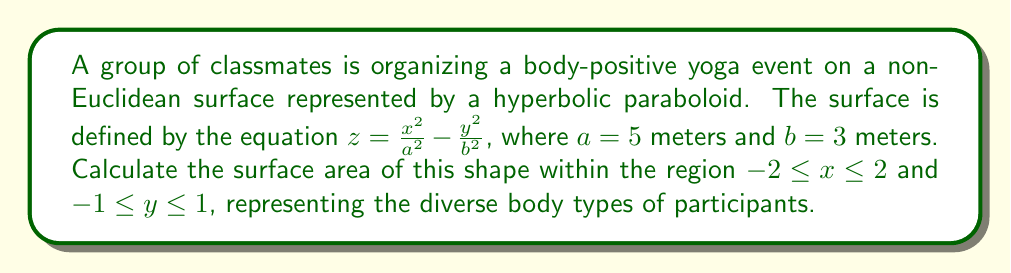Show me your answer to this math problem. To calculate the surface area of the hyperbolic paraboloid within the given region, we'll follow these steps:

1) The surface area of a parametric surface is given by the double integral:

   $$ A = \int\int_R \sqrt{1 + \left(\frac{\partial z}{\partial x}\right)^2 + \left(\frac{\partial z}{\partial y}\right)^2} \, dx \, dy $$

2) Calculate partial derivatives:
   $$ \frac{\partial z}{\partial x} = \frac{2x}{a^2} = \frac{2x}{25} $$
   $$ \frac{\partial z}{\partial y} = -\frac{2y}{b^2} = -\frac{2y}{9} $$

3) Substitute into the formula:
   $$ A = \int_{-1}^1 \int_{-2}^2 \sqrt{1 + \left(\frac{2x}{25}\right)^2 + \left(-\frac{2y}{9}\right)^2} \, dx \, dy $$

4) This integral is difficult to evaluate analytically. We'll use numerical integration methods to approximate the result.

5) Using a numerical integration tool or computer algebra system, we evaluate the double integral:

   $$ A \approx 8.261 \text{ square meters} $$

This result represents the approximate surface area of the hyperbolic paraboloid within the specified region.
Answer: $8.261 \text{ m}^2$ 